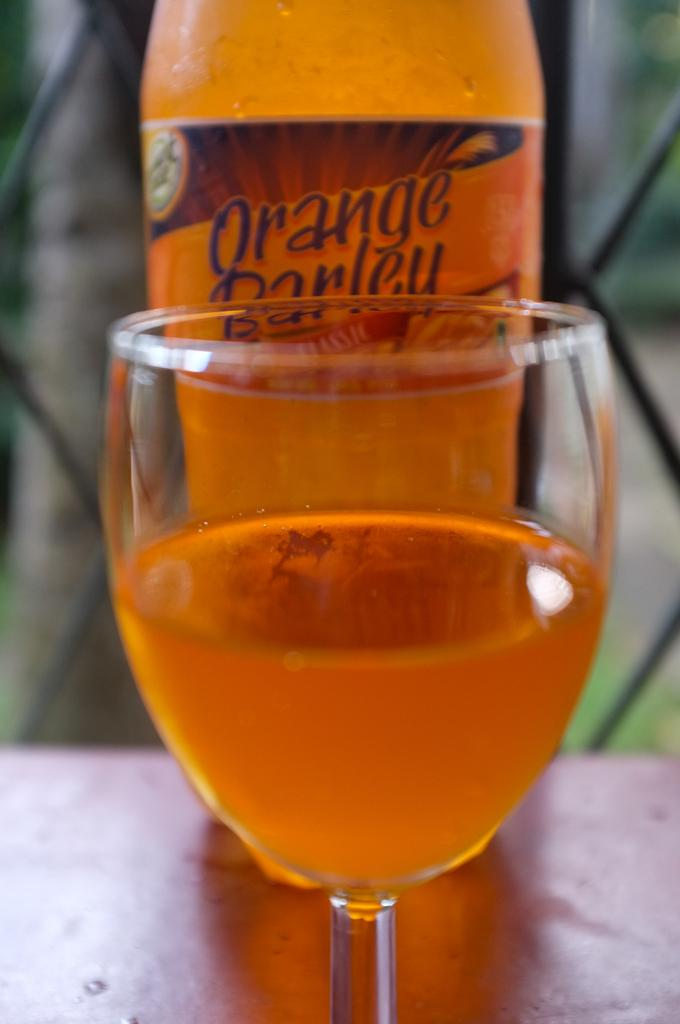Provide a one-sentence caption for the provided image. A glass half full in front of a bottle of Orange Barley. 